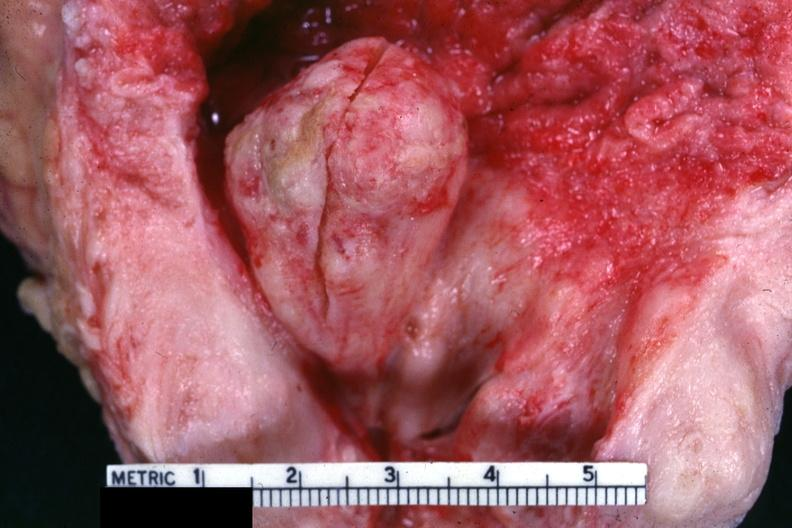does cystadenocarcinoma malignancy show good example of nodule protruding into bladder?
Answer the question using a single word or phrase. No 